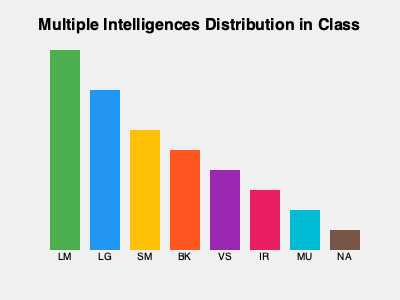Based on the infographic showing the distribution of multiple intelligences in a classroom, which intelligence type appears to be the most prevalent, and how might this information be used to support the unique talents of students? To answer this question, we need to analyze the infographic and consider its implications for teaching:

1. Interpret the graph:
   - The x-axis shows different types of intelligences: LM, LG, SM, BK, VS, IR, MU, and NA.
   - The y-axis represents the prevalence of each intelligence type.
   - The height of each bar indicates the relative frequency of that intelligence type in the classroom.

2. Identify the most prevalent intelligence:
   - The tallest bar corresponds to LM (Linguistic-Mathematical intelligence).
   - This suggests that LM is the most common intelligence type in this classroom.

3. Understanding multiple intelligences theory:
   - LM: Linguistic-Mathematical
   - LG: Logical
   - SM: Spatial-Mathematical
   - BK: Bodily-Kinesthetic
   - VS: Visual-Spatial
   - IR: Interpersonal
   - MU: Musical
   - NA: Naturalistic

4. Implications for supporting unique talents:
   - Recognize that while LM is most common, other intelligences are also present.
   - Design diverse activities that cater to all intelligence types.
   - Use LM strengths as a foundation to introduce and reinforce concepts.
   - Create opportunities for students with less common intelligences to showcase their talents.
   - Implement collaborative projects that allow students to leverage their diverse strengths.
   - Provide personalized learning paths that align with each student's dominant intelligence type.
   - Use varied assessment methods to allow all students to demonstrate their understanding.

5. Benefits of this approach:
   - Increases student engagement by addressing individual learning preferences.
   - Promotes inclusivity and celebrates diversity in the classroom.
   - Helps students develop a growth mindset by exploring different ways of learning.
   - Prepares students for real-world scenarios that require multiple skill sets.

By recognizing and supporting the diverse intelligences in the classroom, a teacher can create a more inclusive and effective learning environment that nurtures each student's unique talents and interests.
Answer: Linguistic-Mathematical (LM) is most prevalent; use this information to design diverse activities catering to all intelligence types, while leveraging LM strengths to introduce concepts and providing opportunities for less common intelligences to shine. 